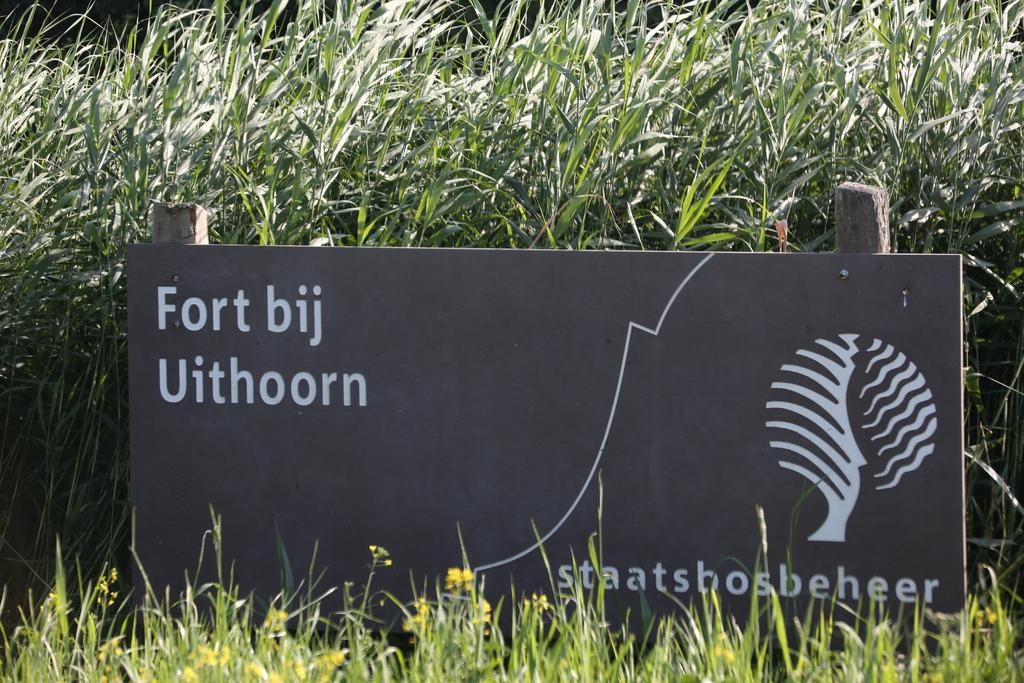What type of living organisms can be seen in the image? There are flowers and plants visible in the image. What else is present on the board in the image? There is an image on the board, along with text. What type of sponge is being used to water the plants in the image? There is no sponge visible in the image, and it is not mentioned that the plants are being watered. 